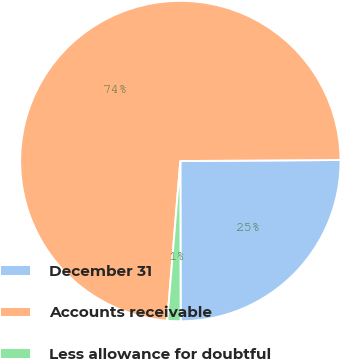Convert chart to OTSL. <chart><loc_0><loc_0><loc_500><loc_500><pie_chart><fcel>December 31<fcel>Accounts receivable<fcel>Less allowance for doubtful<nl><fcel>25.08%<fcel>73.6%<fcel>1.33%<nl></chart> 